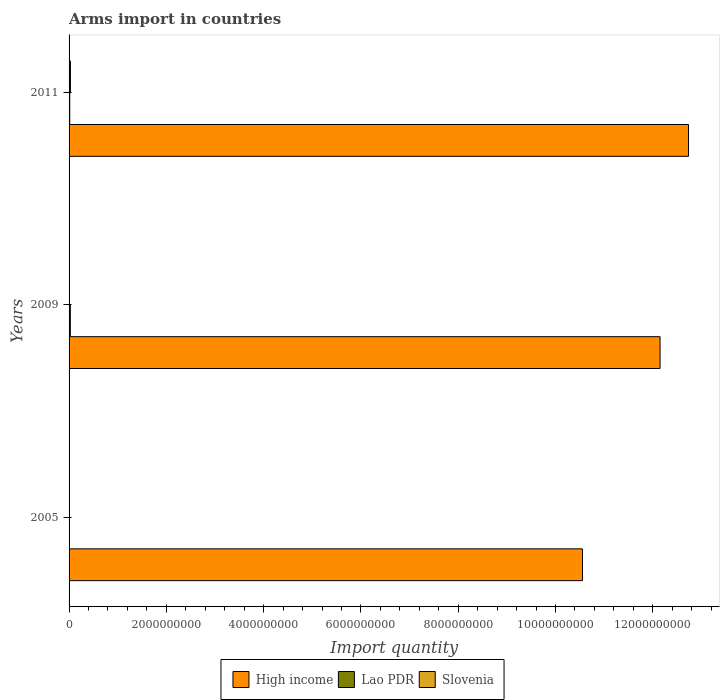How many different coloured bars are there?
Make the answer very short. 3. How many groups of bars are there?
Offer a very short reply. 3. How many bars are there on the 2nd tick from the top?
Your response must be concise. 3. What is the label of the 1st group of bars from the top?
Offer a very short reply. 2011. In how many cases, is the number of bars for a given year not equal to the number of legend labels?
Make the answer very short. 0. What is the total arms import in Slovenia in 2011?
Ensure brevity in your answer.  2.80e+07. Across all years, what is the maximum total arms import in Slovenia?
Your answer should be very brief. 2.80e+07. Across all years, what is the minimum total arms import in High income?
Make the answer very short. 1.06e+1. In which year was the total arms import in Lao PDR minimum?
Your answer should be compact. 2005. What is the total total arms import in Slovenia in the graph?
Offer a terse response. 3.70e+07. What is the difference between the total arms import in High income in 2005 and that in 2009?
Provide a short and direct response. -1.60e+09. What is the difference between the total arms import in High income in 2005 and the total arms import in Slovenia in 2009?
Provide a succinct answer. 1.05e+1. What is the average total arms import in High income per year?
Ensure brevity in your answer.  1.18e+1. In the year 2009, what is the difference between the total arms import in Lao PDR and total arms import in Slovenia?
Offer a terse response. 2.00e+07. What is the ratio of the total arms import in Slovenia in 2005 to that in 2011?
Offer a terse response. 0.11. Is the difference between the total arms import in Lao PDR in 2009 and 2011 greater than the difference between the total arms import in Slovenia in 2009 and 2011?
Keep it short and to the point. Yes. What is the difference between the highest and the second highest total arms import in Slovenia?
Ensure brevity in your answer.  2.20e+07. What is the difference between the highest and the lowest total arms import in High income?
Provide a succinct answer. 2.18e+09. In how many years, is the total arms import in Slovenia greater than the average total arms import in Slovenia taken over all years?
Ensure brevity in your answer.  1. Is the sum of the total arms import in Lao PDR in 2009 and 2011 greater than the maximum total arms import in Slovenia across all years?
Ensure brevity in your answer.  Yes. What does the 1st bar from the top in 2005 represents?
Give a very brief answer. Slovenia. What does the 3rd bar from the bottom in 2009 represents?
Ensure brevity in your answer.  Slovenia. Are all the bars in the graph horizontal?
Your answer should be compact. Yes. What is the difference between two consecutive major ticks on the X-axis?
Offer a very short reply. 2.00e+09. Are the values on the major ticks of X-axis written in scientific E-notation?
Ensure brevity in your answer.  No. Does the graph contain any zero values?
Provide a short and direct response. No. Does the graph contain grids?
Your answer should be compact. No. Where does the legend appear in the graph?
Offer a very short reply. Bottom center. How are the legend labels stacked?
Give a very brief answer. Horizontal. What is the title of the graph?
Offer a terse response. Arms import in countries. What is the label or title of the X-axis?
Offer a very short reply. Import quantity. What is the label or title of the Y-axis?
Offer a very short reply. Years. What is the Import quantity in High income in 2005?
Give a very brief answer. 1.06e+1. What is the Import quantity of Lao PDR in 2005?
Provide a short and direct response. 4.00e+06. What is the Import quantity in High income in 2009?
Offer a very short reply. 1.21e+1. What is the Import quantity of Lao PDR in 2009?
Your answer should be compact. 2.60e+07. What is the Import quantity of Slovenia in 2009?
Make the answer very short. 6.00e+06. What is the Import quantity of High income in 2011?
Provide a short and direct response. 1.27e+1. What is the Import quantity of Lao PDR in 2011?
Give a very brief answer. 1.40e+07. What is the Import quantity in Slovenia in 2011?
Your answer should be compact. 2.80e+07. Across all years, what is the maximum Import quantity of High income?
Offer a very short reply. 1.27e+1. Across all years, what is the maximum Import quantity in Lao PDR?
Your response must be concise. 2.60e+07. Across all years, what is the maximum Import quantity in Slovenia?
Your answer should be very brief. 2.80e+07. Across all years, what is the minimum Import quantity of High income?
Ensure brevity in your answer.  1.06e+1. Across all years, what is the minimum Import quantity of Lao PDR?
Your answer should be very brief. 4.00e+06. Across all years, what is the minimum Import quantity in Slovenia?
Keep it short and to the point. 3.00e+06. What is the total Import quantity of High income in the graph?
Ensure brevity in your answer.  3.54e+1. What is the total Import quantity of Lao PDR in the graph?
Keep it short and to the point. 4.40e+07. What is the total Import quantity of Slovenia in the graph?
Your response must be concise. 3.70e+07. What is the difference between the Import quantity in High income in 2005 and that in 2009?
Keep it short and to the point. -1.60e+09. What is the difference between the Import quantity in Lao PDR in 2005 and that in 2009?
Ensure brevity in your answer.  -2.20e+07. What is the difference between the Import quantity of Slovenia in 2005 and that in 2009?
Provide a short and direct response. -3.00e+06. What is the difference between the Import quantity of High income in 2005 and that in 2011?
Provide a succinct answer. -2.18e+09. What is the difference between the Import quantity in Lao PDR in 2005 and that in 2011?
Provide a succinct answer. -1.00e+07. What is the difference between the Import quantity of Slovenia in 2005 and that in 2011?
Make the answer very short. -2.50e+07. What is the difference between the Import quantity in High income in 2009 and that in 2011?
Offer a very short reply. -5.85e+08. What is the difference between the Import quantity of Slovenia in 2009 and that in 2011?
Make the answer very short. -2.20e+07. What is the difference between the Import quantity in High income in 2005 and the Import quantity in Lao PDR in 2009?
Give a very brief answer. 1.05e+1. What is the difference between the Import quantity in High income in 2005 and the Import quantity in Slovenia in 2009?
Give a very brief answer. 1.05e+1. What is the difference between the Import quantity of Lao PDR in 2005 and the Import quantity of Slovenia in 2009?
Provide a short and direct response. -2.00e+06. What is the difference between the Import quantity of High income in 2005 and the Import quantity of Lao PDR in 2011?
Provide a short and direct response. 1.05e+1. What is the difference between the Import quantity of High income in 2005 and the Import quantity of Slovenia in 2011?
Make the answer very short. 1.05e+1. What is the difference between the Import quantity of Lao PDR in 2005 and the Import quantity of Slovenia in 2011?
Your response must be concise. -2.40e+07. What is the difference between the Import quantity of High income in 2009 and the Import quantity of Lao PDR in 2011?
Provide a short and direct response. 1.21e+1. What is the difference between the Import quantity of High income in 2009 and the Import quantity of Slovenia in 2011?
Provide a succinct answer. 1.21e+1. What is the difference between the Import quantity in Lao PDR in 2009 and the Import quantity in Slovenia in 2011?
Give a very brief answer. -2.00e+06. What is the average Import quantity of High income per year?
Your answer should be very brief. 1.18e+1. What is the average Import quantity in Lao PDR per year?
Give a very brief answer. 1.47e+07. What is the average Import quantity in Slovenia per year?
Give a very brief answer. 1.23e+07. In the year 2005, what is the difference between the Import quantity in High income and Import quantity in Lao PDR?
Give a very brief answer. 1.06e+1. In the year 2005, what is the difference between the Import quantity in High income and Import quantity in Slovenia?
Provide a succinct answer. 1.06e+1. In the year 2009, what is the difference between the Import quantity in High income and Import quantity in Lao PDR?
Give a very brief answer. 1.21e+1. In the year 2009, what is the difference between the Import quantity in High income and Import quantity in Slovenia?
Your response must be concise. 1.21e+1. In the year 2011, what is the difference between the Import quantity in High income and Import quantity in Lao PDR?
Make the answer very short. 1.27e+1. In the year 2011, what is the difference between the Import quantity in High income and Import quantity in Slovenia?
Provide a short and direct response. 1.27e+1. In the year 2011, what is the difference between the Import quantity of Lao PDR and Import quantity of Slovenia?
Provide a short and direct response. -1.40e+07. What is the ratio of the Import quantity in High income in 2005 to that in 2009?
Keep it short and to the point. 0.87. What is the ratio of the Import quantity in Lao PDR in 2005 to that in 2009?
Provide a succinct answer. 0.15. What is the ratio of the Import quantity of High income in 2005 to that in 2011?
Your answer should be very brief. 0.83. What is the ratio of the Import quantity in Lao PDR in 2005 to that in 2011?
Your answer should be compact. 0.29. What is the ratio of the Import quantity of Slovenia in 2005 to that in 2011?
Your response must be concise. 0.11. What is the ratio of the Import quantity of High income in 2009 to that in 2011?
Give a very brief answer. 0.95. What is the ratio of the Import quantity of Lao PDR in 2009 to that in 2011?
Give a very brief answer. 1.86. What is the ratio of the Import quantity of Slovenia in 2009 to that in 2011?
Give a very brief answer. 0.21. What is the difference between the highest and the second highest Import quantity in High income?
Keep it short and to the point. 5.85e+08. What is the difference between the highest and the second highest Import quantity in Slovenia?
Make the answer very short. 2.20e+07. What is the difference between the highest and the lowest Import quantity of High income?
Give a very brief answer. 2.18e+09. What is the difference between the highest and the lowest Import quantity of Lao PDR?
Offer a terse response. 2.20e+07. What is the difference between the highest and the lowest Import quantity in Slovenia?
Make the answer very short. 2.50e+07. 